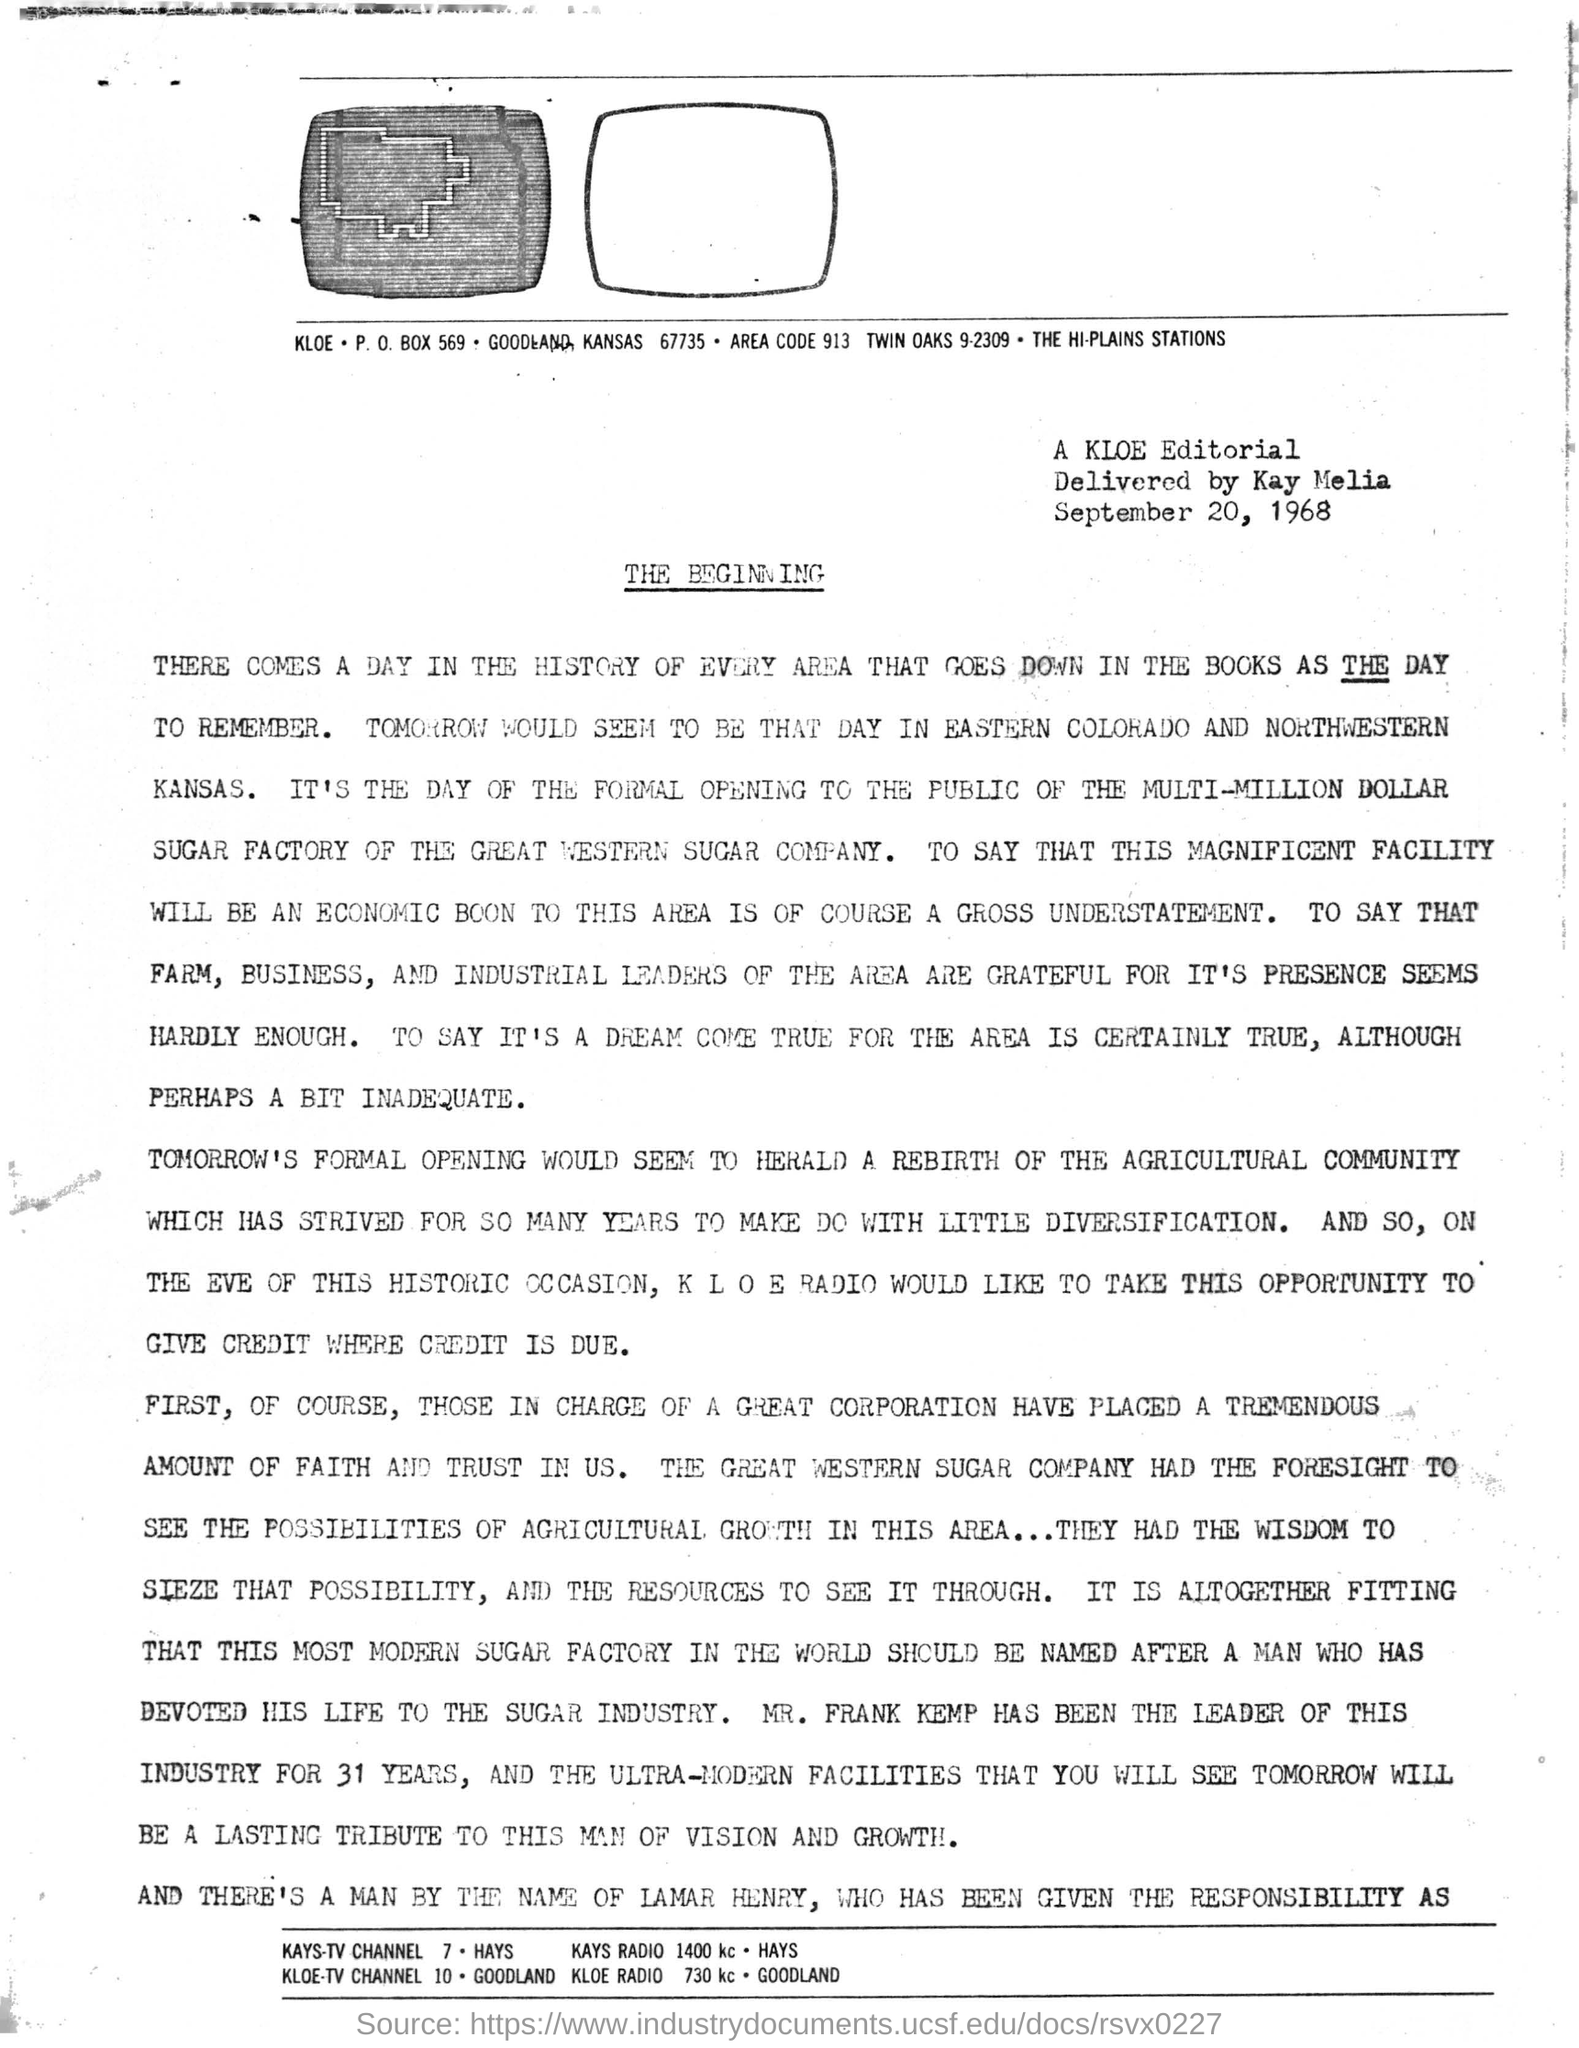Point out several critical features in this image. Kay Melia delivered the Editorial. The P.O. Box number written under the first image is 569. The area code written under the image is 913. 